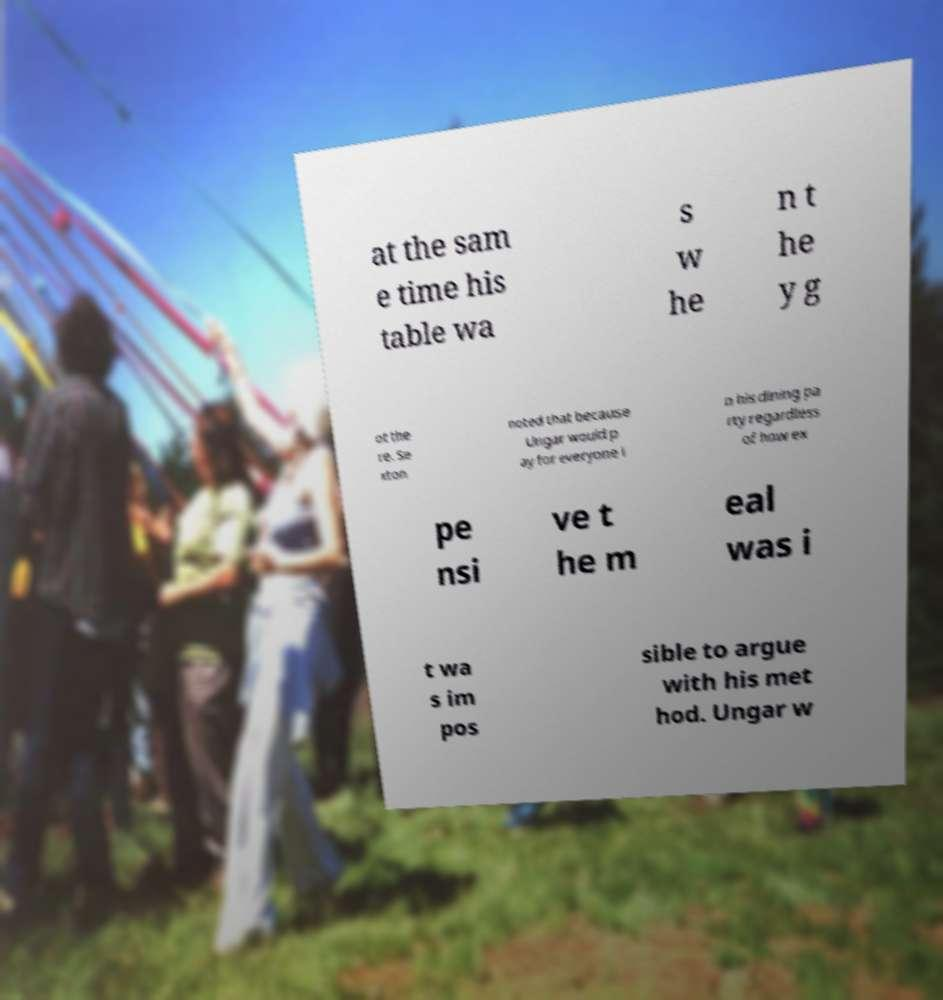Please identify and transcribe the text found in this image. at the sam e time his table wa s w he n t he y g ot the re. Se xton noted that because Ungar would p ay for everyone i n his dining pa rty regardless of how ex pe nsi ve t he m eal was i t wa s im pos sible to argue with his met hod. Ungar w 